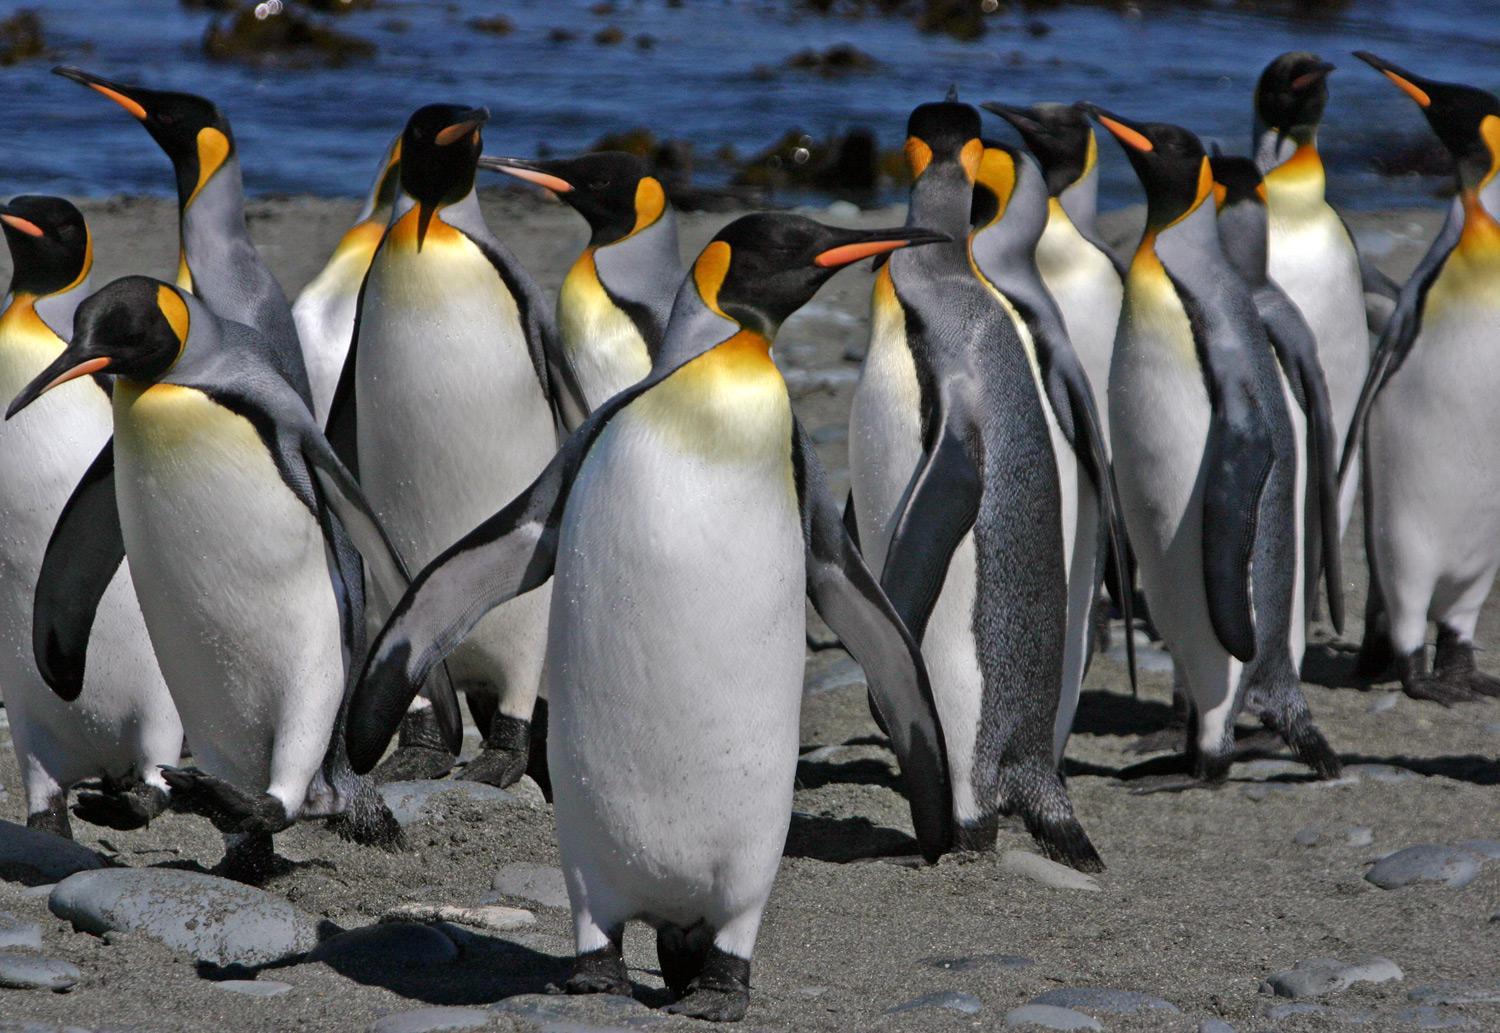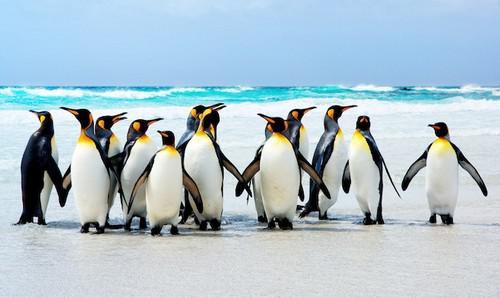The first image is the image on the left, the second image is the image on the right. Given the left and right images, does the statement "An image shows a horizontal row of upright penguins, all facing right." hold true? Answer yes or no. No. The first image is the image on the left, the second image is the image on the right. Given the left and right images, does the statement "multiple peguins white bellies are facing the camera" hold true? Answer yes or no. Yes. 